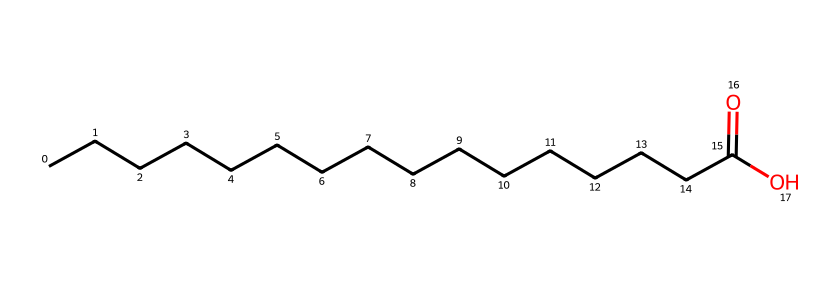What is the total number of carbon atoms in this chemical? The SMILES representation shows a long carbon chain where "CCCCCCCCCCCCCCCC" indicates each "C" stands for one carbon atom. Counting the "C"s gives us a total of 16 carbon atoms.
Answer: 16 How many hydrogen atoms are present in this chemical? Each carbon atom is typically bonded to enough hydrogen atoms to make four bonds total. In this structure, there are 16 carbon atoms in a chain, and the terminal -COOH group contributes one hydrogen atom. Thus, the total number of hydrogens is 2 x 16 (for the chain) - 1 (because one carbon is double-bonded to oxygen in the carboxylic acid group) = 31.
Answer: 32 What functional group is present in this chemical? The presence of the "O" and "OH" at the end of the chemical indicates a carboxylic acid functional group (–COOH). This structure is characteristic of acids.
Answer: carboxylic acid What type of bond connects the carbon atoms in this chemical? The structure contains carbon atoms connected primarily by single bonds (sigma bonds), as there is no indication of any double or triple bonds between the carbon atoms. The oxygen double bond in the fat end does not change the type of bonds connecting the carbon atoms in the chain.
Answer: single bonds Is this molecule hydrophobic or hydrophilic? The long carbon chain makes this molecule primarily hydrophobic, while the -COOH group provides some hydrophilicity due to its ability to interact with water. Overall, it tends to be more hydrophobic because of its large nonpolar carbon section.
Answer: hydrophobic How does this chemical behave in water? When this chemical is placed in water, the polar carboxylic acid end can form hydrogen bonds with water, while its long nonpolar carbon chain tends to repel water. This also means it could function as a surfactant, helping to reduce surface tension between water and oils.
Answer: behaves as a surfactant 